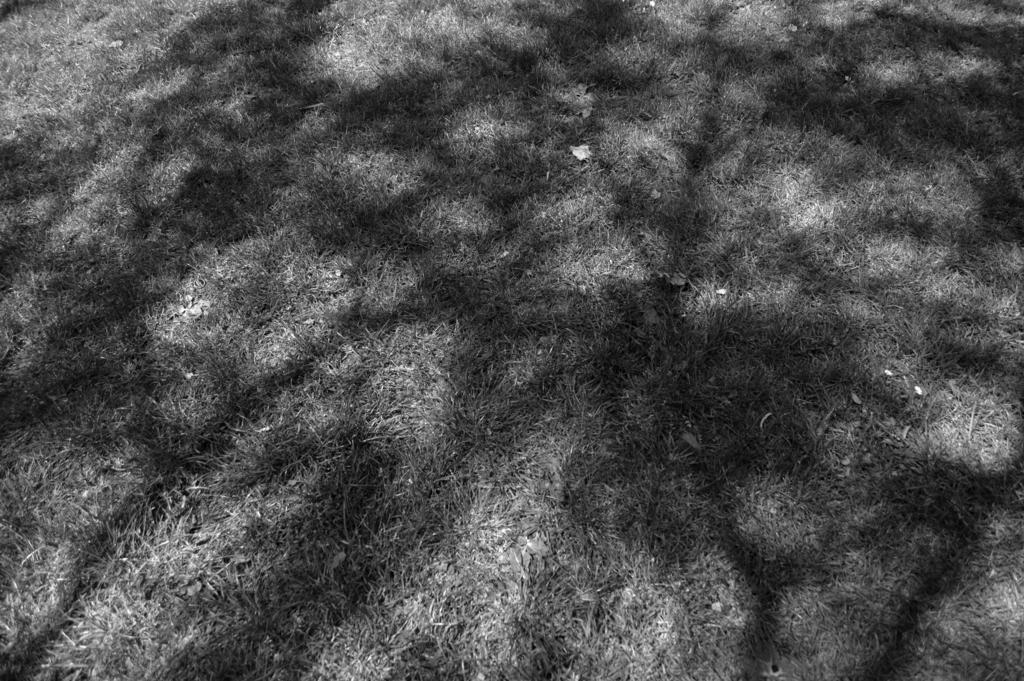What is the color scheme of the image? The image is black and white. What type of vegetation can be seen on the ground in the image? There is grass on the ground in the image. What type of wood can be seen in the image? There is no wood present in the image; it only features grass on the ground. What type of dirt is visible in the image? There is no dirt visible in the image; it only features grass on the ground. 